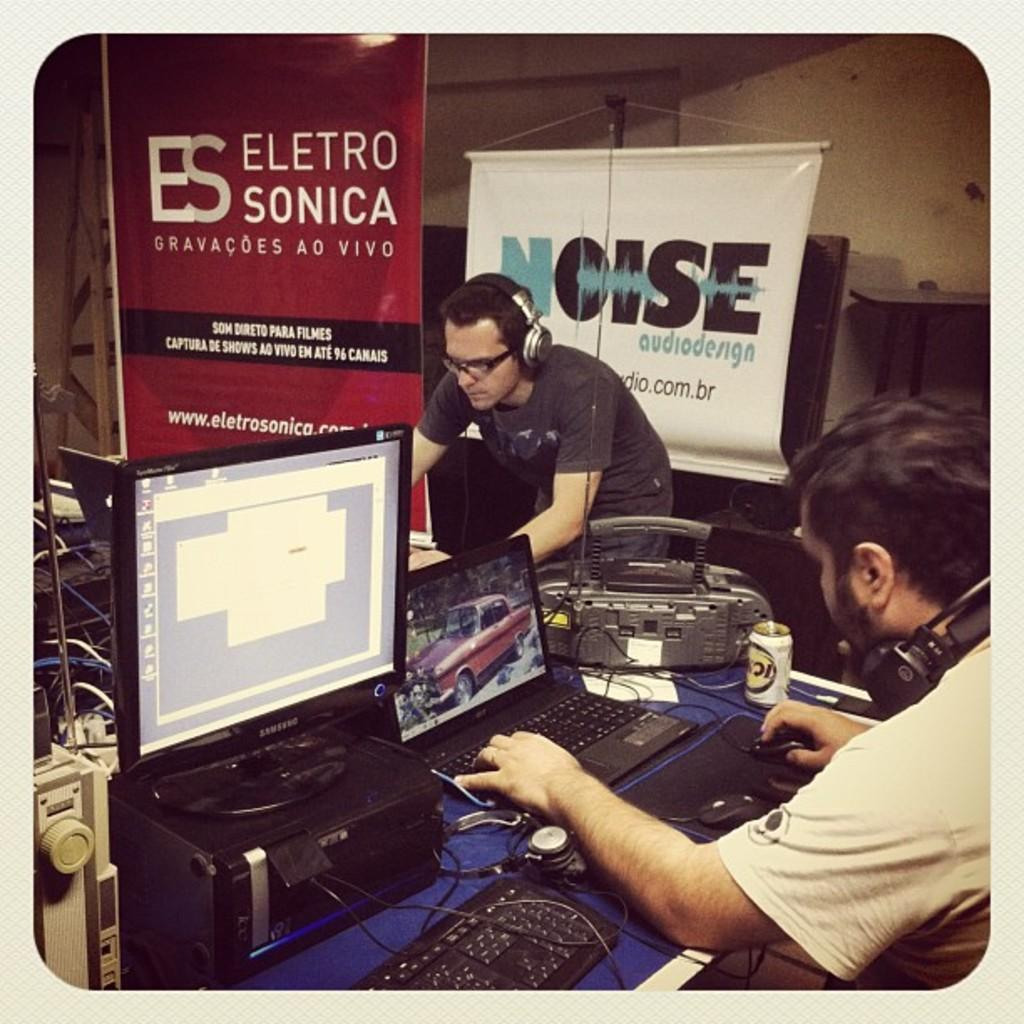Provide a one-sentence caption for the provided image. Some men are working with their laptop with a banner from Eletro Sonica in the background. 